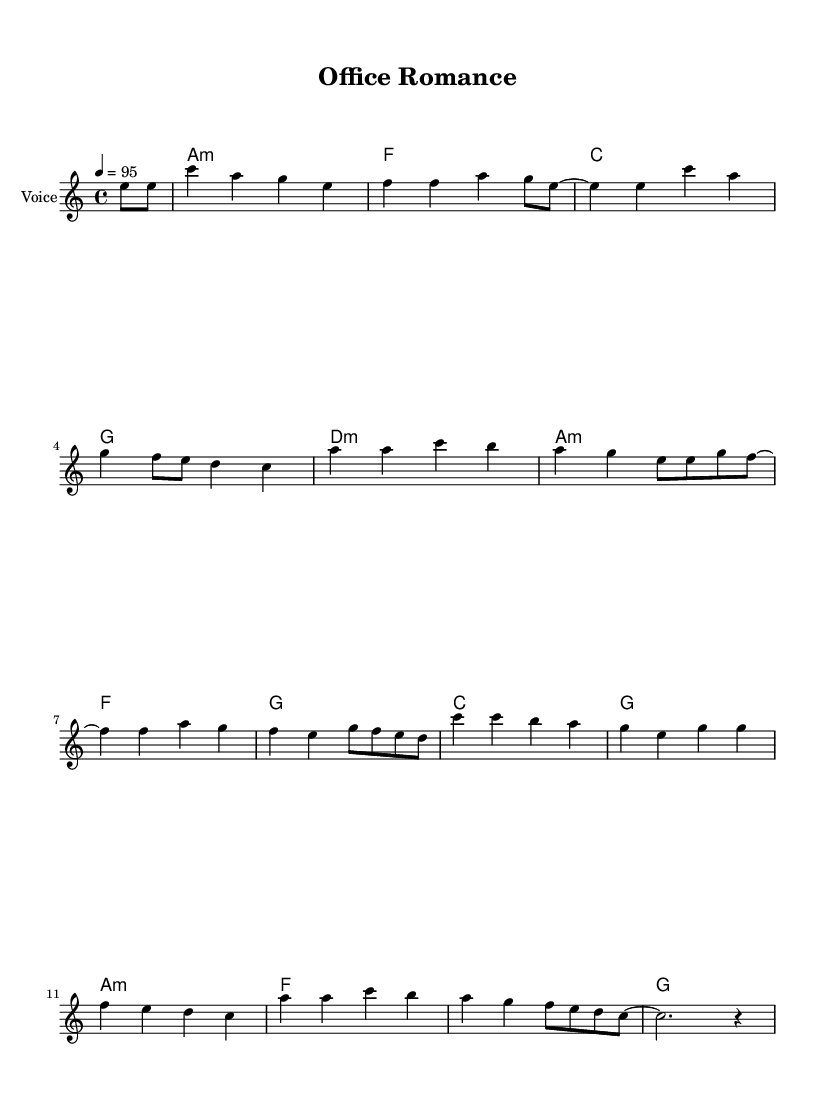What is the key signature of this music? The key signature is identified at the beginning of the sheet music. The notation shows one flat, which indicates A minor, as it is the relative minor of C major.
Answer: A minor What is the time signature of this music? The time signature is indicated at the beginning of the score as well. It shows 4/4, meaning there are four beats in each measure and a quarter note receives one beat.
Answer: 4/4 What is the tempo marking for this piece? The tempo marking is provided in the score, which specifies the speed of the piece. It reads "4 = 95," indicating that there should be 95 quarter note beats per minute.
Answer: 95 How many measures are in the melody? To determine the number of measures, we can count the individual segments of music separated by vertical lines, which indicate the end of each measure. There are 16 measures in total.
Answer: 16 What is the theme of the lyrics in this song? Analyzing the lyrics reveals that they revolve around themes of office romance, with a narrative focusing on relationships developed in the workplace. This can be inferred from phrases like "office romance" and "careers on the line."
Answer: Office romance Which chord is played first in the harmonic progression? The first chord listed in the harmonic section is labeled "a1:m," which indicates an A minor chord. This chord sets the tonal foundation for the piece.
Answer: A minor 